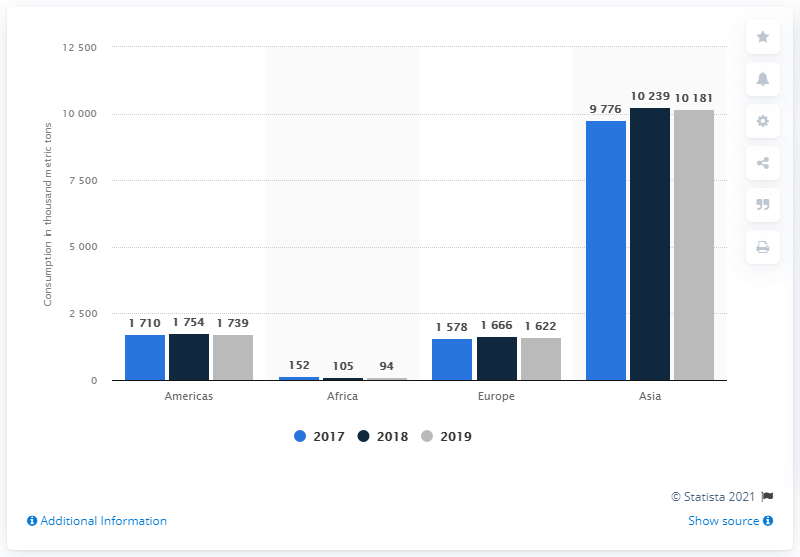Highlight a few significant elements in this photo. The country that consumes the largest amount of natural rubber worldwide is Asia. 